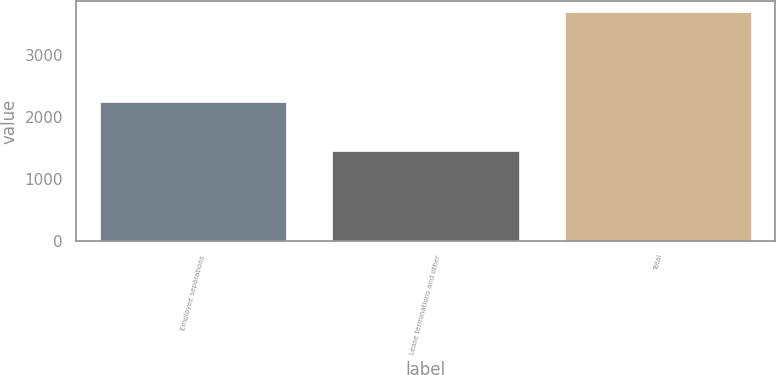Convert chart to OTSL. <chart><loc_0><loc_0><loc_500><loc_500><bar_chart><fcel>Employee separations<fcel>Lease terminations and other<fcel>Total<nl><fcel>2239<fcel>1450<fcel>3689<nl></chart> 